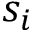Convert formula to latex. <formula><loc_0><loc_0><loc_500><loc_500>s _ { i }</formula> 